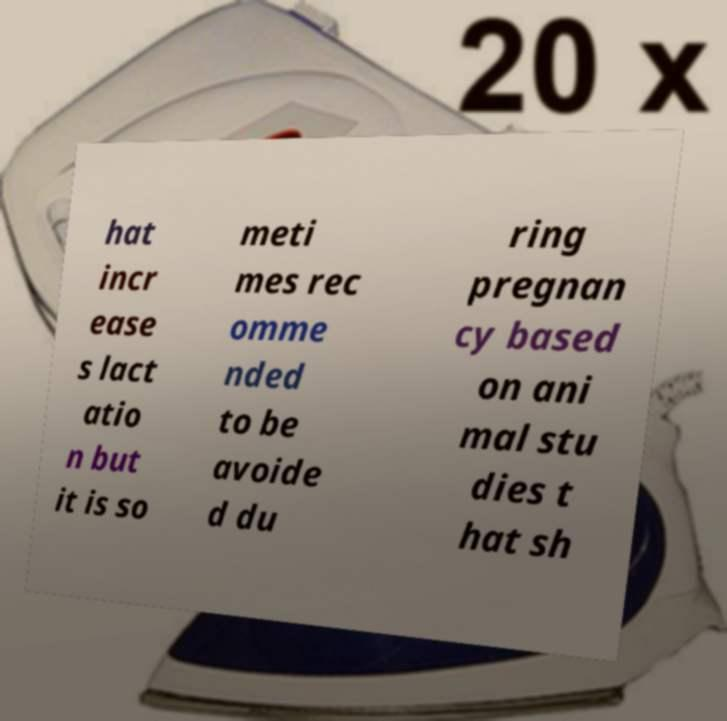Can you read and provide the text displayed in the image?This photo seems to have some interesting text. Can you extract and type it out for me? hat incr ease s lact atio n but it is so meti mes rec omme nded to be avoide d du ring pregnan cy based on ani mal stu dies t hat sh 